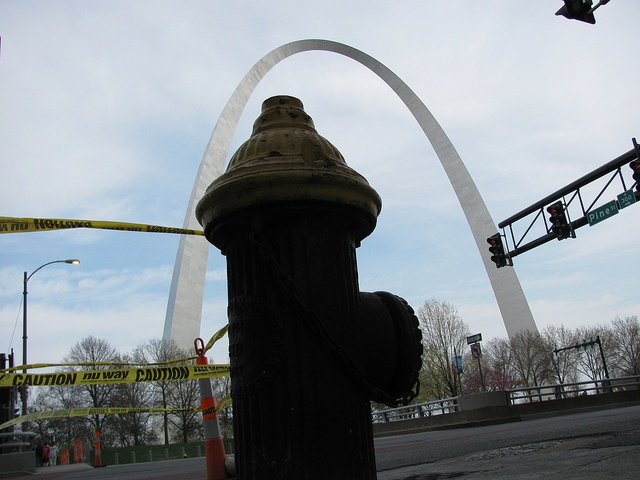Describe the objects in this image and their specific colors. I can see fire hydrant in lavender, black, and gray tones, traffic light in lightgray, black, navy, lavender, and gray tones, traffic light in lightgray, black, purple, and gray tones, traffic light in lightgray, black, darkgray, gray, and maroon tones, and traffic light in lightgray, black, purple, and navy tones in this image. 